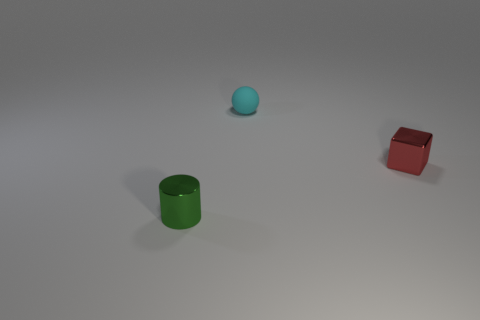What is the small object that is behind the small metal block made of?
Provide a succinct answer. Rubber. What number of things are either big yellow shiny cylinders or tiny things?
Give a very brief answer. 3. There is a ball that is to the left of the tiny red metallic cube; what is its color?
Offer a terse response. Cyan. What number of things are either metallic things that are left of the rubber sphere or small things on the right side of the green metal thing?
Your answer should be compact. 3. Is the shape of the cyan rubber thing the same as the shiny thing in front of the block?
Ensure brevity in your answer.  No. How many objects are tiny objects that are to the left of the tiny sphere or rubber spheres?
Your response must be concise. 2. Do the tiny red thing and the green object to the left of the cyan rubber ball have the same material?
Offer a very short reply. Yes. What is the shape of the small metal thing right of the green cylinder in front of the red block?
Ensure brevity in your answer.  Cube. Is there any other thing that has the same material as the cyan object?
Provide a succinct answer. No. What is the shape of the small green object?
Make the answer very short. Cylinder. 